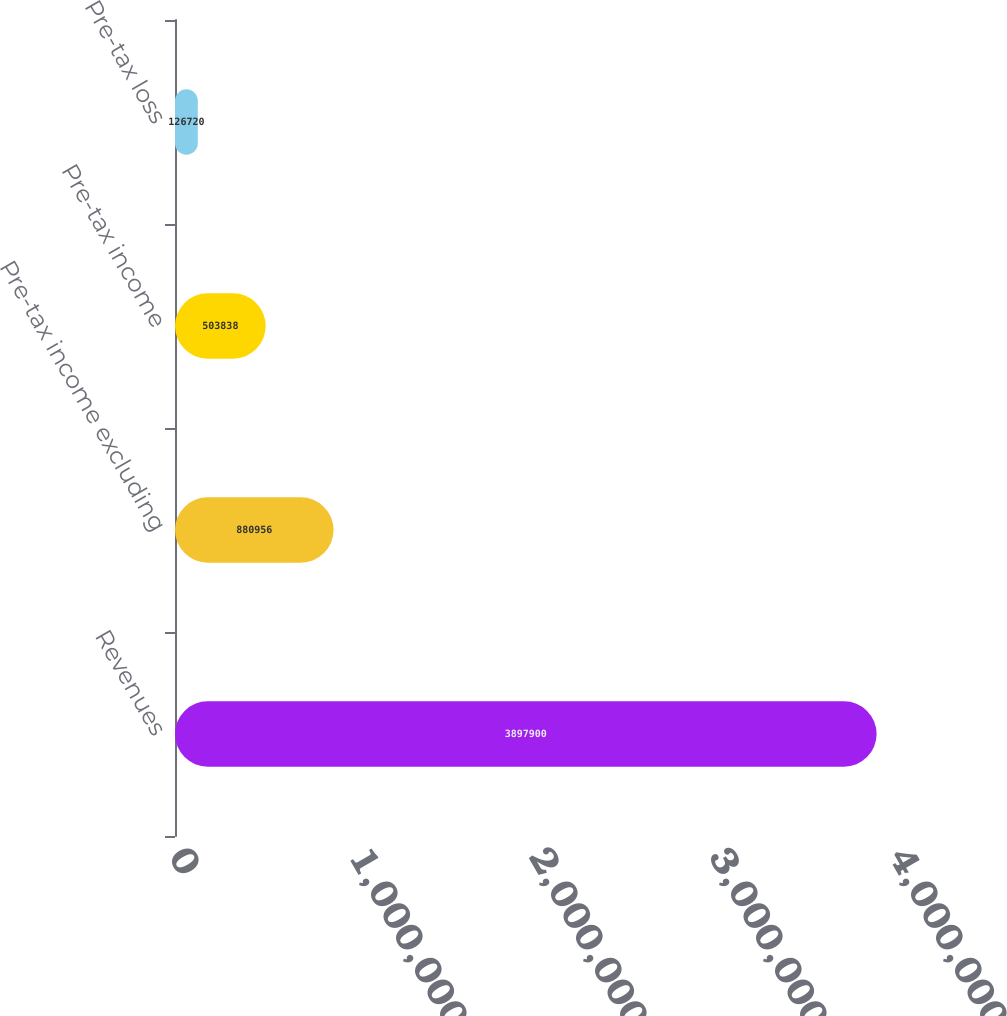Convert chart to OTSL. <chart><loc_0><loc_0><loc_500><loc_500><bar_chart><fcel>Revenues<fcel>Pre-tax income excluding<fcel>Pre-tax income<fcel>Pre-tax loss<nl><fcel>3.8979e+06<fcel>880956<fcel>503838<fcel>126720<nl></chart> 